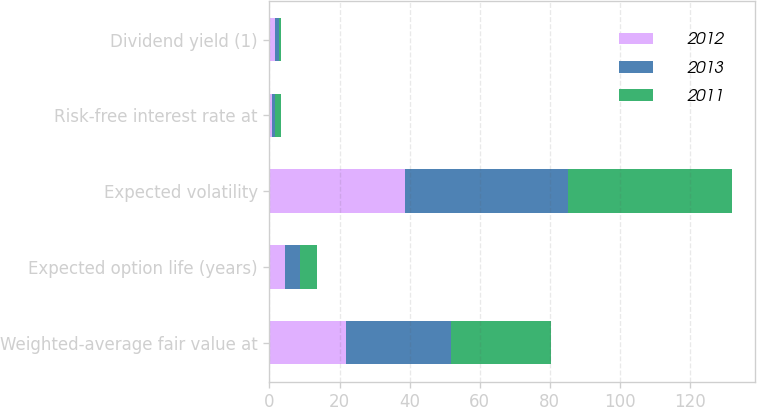Convert chart. <chart><loc_0><loc_0><loc_500><loc_500><stacked_bar_chart><ecel><fcel>Weighted-average fair value at<fcel>Expected option life (years)<fcel>Expected volatility<fcel>Risk-free interest rate at<fcel>Dividend yield (1)<nl><fcel>2012<fcel>21.8<fcel>4.4<fcel>38.8<fcel>0.8<fcel>1.5<nl><fcel>2013<fcel>30.15<fcel>4.4<fcel>46.3<fcel>0.8<fcel>1.2<nl><fcel>2011<fcel>28.29<fcel>4.8<fcel>46.8<fcel>1.7<fcel>0.5<nl></chart> 